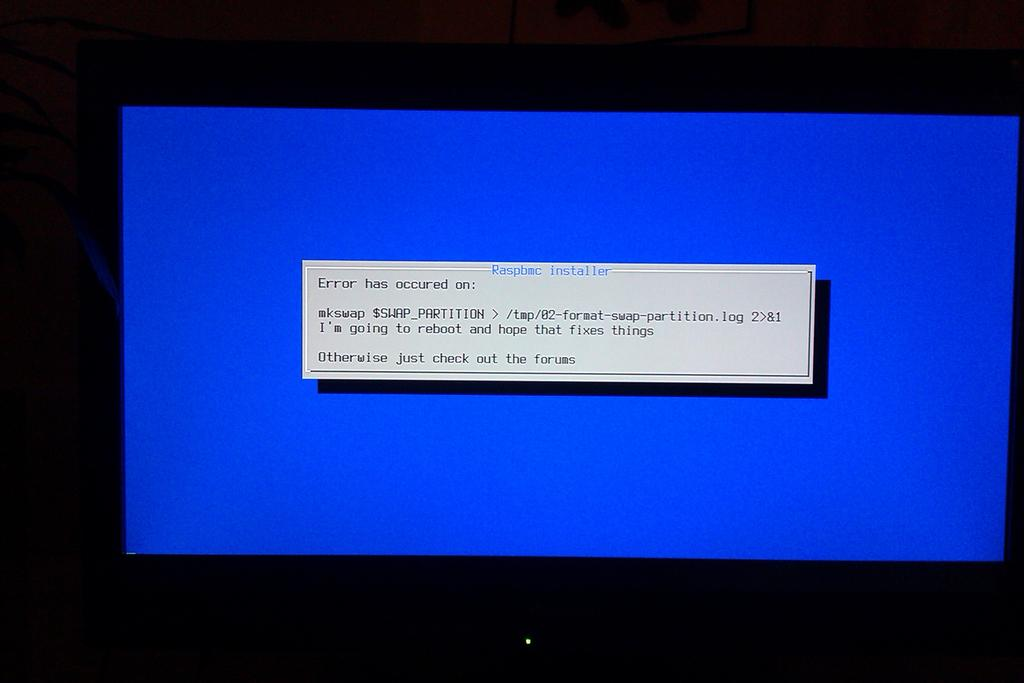<image>
Describe the image concisely. A monitor with a blue background and a text saying an error has occurred. 